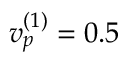Convert formula to latex. <formula><loc_0><loc_0><loc_500><loc_500>v _ { p } ^ { ( 1 ) } = 0 . 5</formula> 